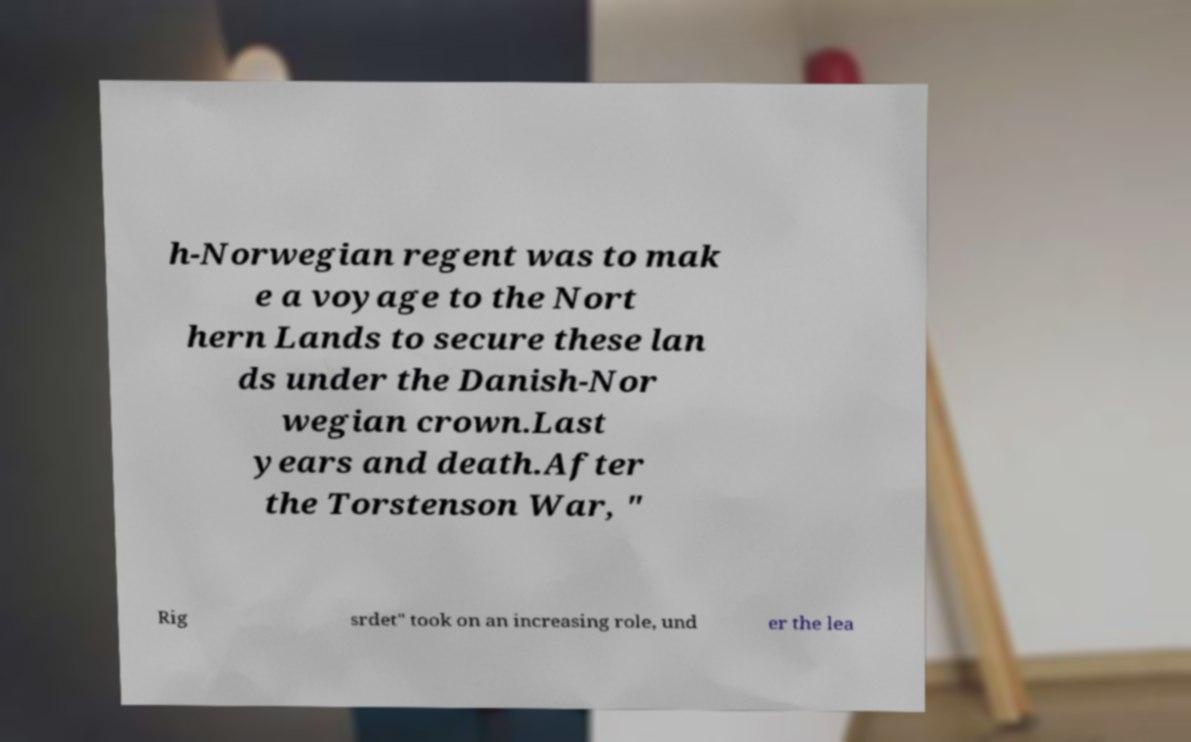There's text embedded in this image that I need extracted. Can you transcribe it verbatim? h-Norwegian regent was to mak e a voyage to the Nort hern Lands to secure these lan ds under the Danish-Nor wegian crown.Last years and death.After the Torstenson War, " Rig srdet" took on an increasing role, und er the lea 